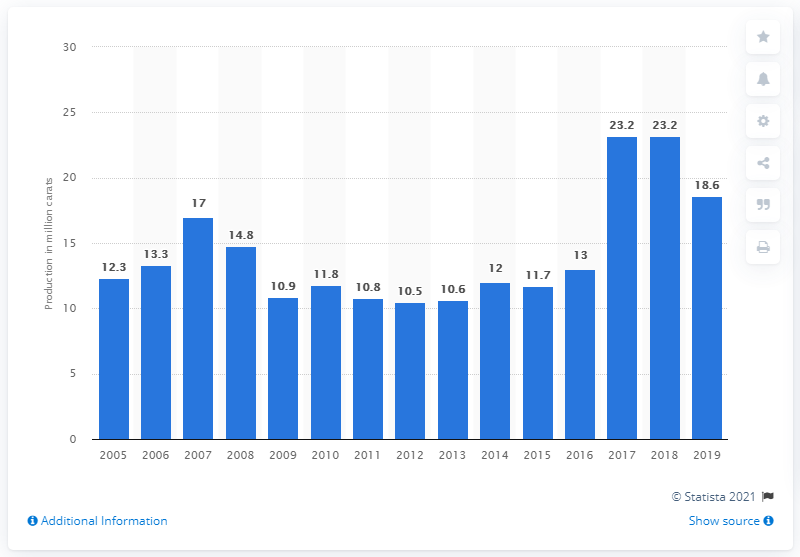Draw attention to some important aspects in this diagram. In 2019, the total production of diamonds in Canada was 18.6 billion carats. In 2019, a total of 23.2 million carats of diamonds were produced in Canada. 